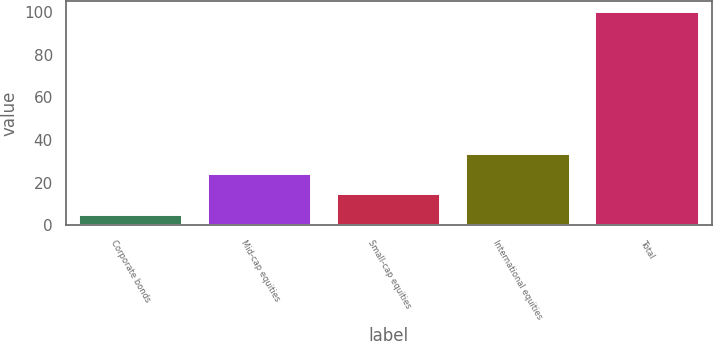<chart> <loc_0><loc_0><loc_500><loc_500><bar_chart><fcel>Corporate bonds<fcel>Mid-cap equities<fcel>Small-cap equities<fcel>International equities<fcel>Total<nl><fcel>5<fcel>24<fcel>14.5<fcel>33.5<fcel>100<nl></chart> 